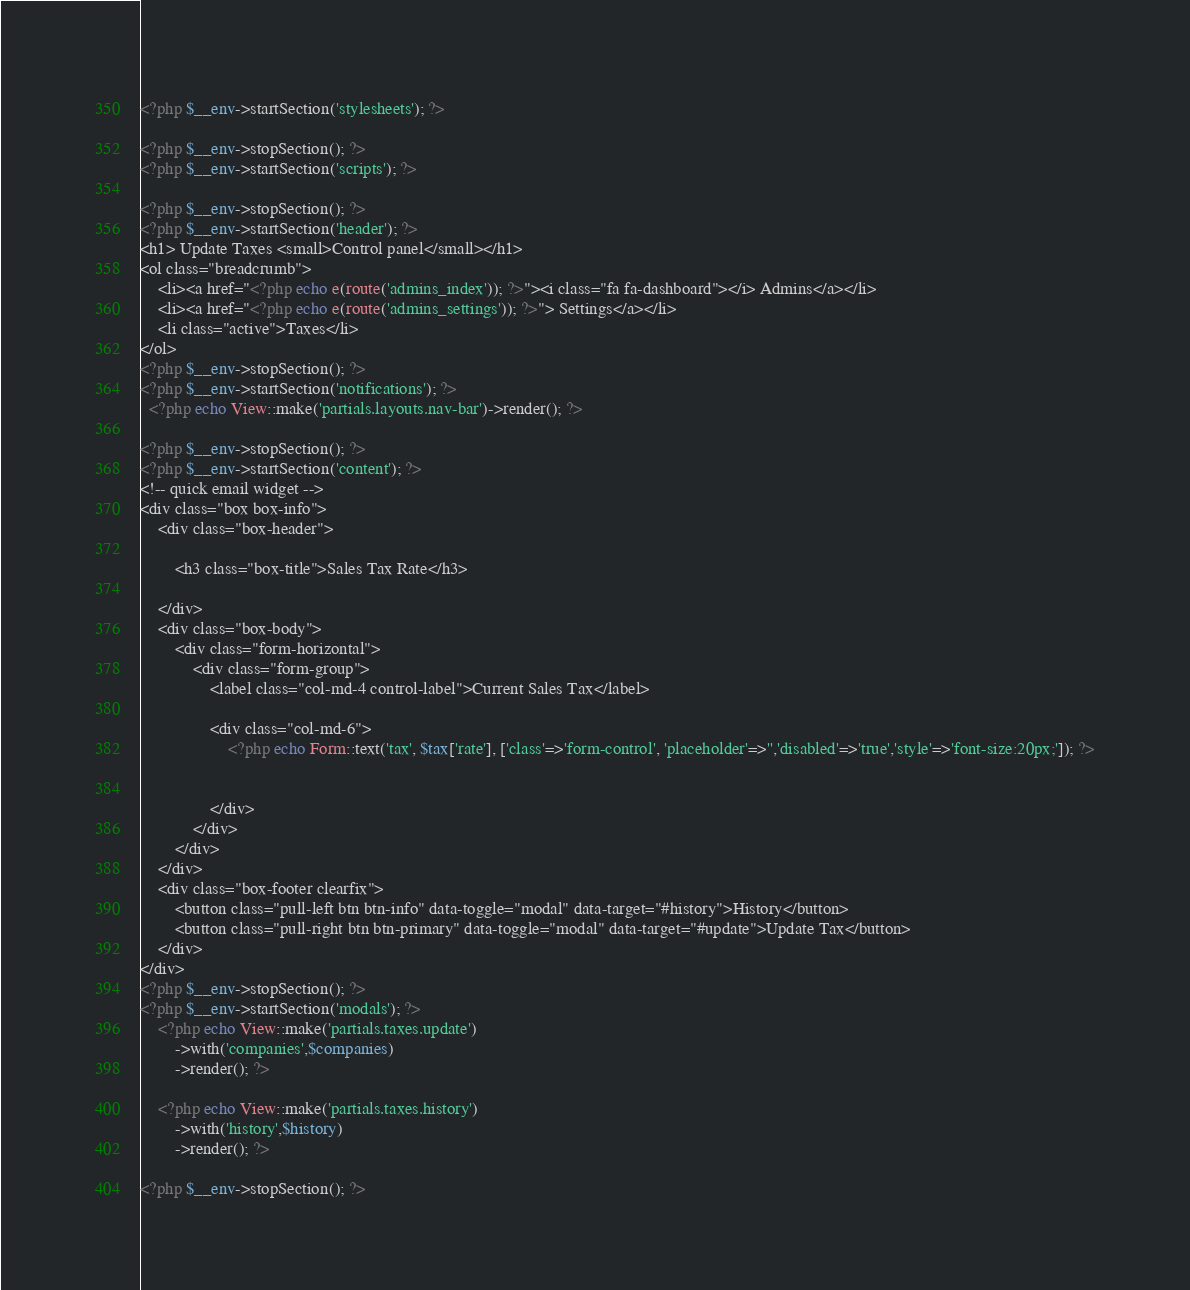Convert code to text. <code><loc_0><loc_0><loc_500><loc_500><_PHP_><?php $__env->startSection('stylesheets'); ?>

<?php $__env->stopSection(); ?>
<?php $__env->startSection('scripts'); ?>

<?php $__env->stopSection(); ?>
<?php $__env->startSection('header'); ?>
<h1> Update Taxes <small>Control panel</small></h1>
<ol class="breadcrumb">
	<li><a href="<?php echo e(route('admins_index')); ?>"><i class="fa fa-dashboard"></i> Admins</a></li>
	<li><a href="<?php echo e(route('admins_settings')); ?>"> Settings</a></li>
	<li class="active">Taxes</li>
</ol>
<?php $__env->stopSection(); ?>
<?php $__env->startSection('notifications'); ?>
  <?php echo View::make('partials.layouts.nav-bar')->render(); ?>

<?php $__env->stopSection(); ?>
<?php $__env->startSection('content'); ?>
<!-- quick email widget -->
<div class="box box-info">
	<div class="box-header">

		<h3 class="box-title">Sales Tax Rate</h3>

	</div>
	<div class="box-body">
		<div class="form-horizontal">
            <div class="form-group">
                <label class="col-md-4 control-label">Current Sales Tax</label>

                <div class="col-md-6">
                    <?php echo Form::text('tax', $tax['rate'], ['class'=>'form-control', 'placeholder'=>'','disabled'=>'true','style'=>'font-size:20px;']); ?>


                </div>
            </div> 				
		</div>
	</div>
	<div class="box-footer clearfix">
		<button class="pull-left btn btn-info" data-toggle="modal" data-target="#history">History</button>
		<button class="pull-right btn btn-primary" data-toggle="modal" data-target="#update">Update Tax</button>
	</div>
</div>
<?php $__env->stopSection(); ?>
<?php $__env->startSection('modals'); ?>
	<?php echo View::make('partials.taxes.update')
		->with('companies',$companies)
		->render(); ?>

	<?php echo View::make('partials.taxes.history')
		->with('history',$history)
		->render(); ?>

<?php $__env->stopSection(); ?></code> 